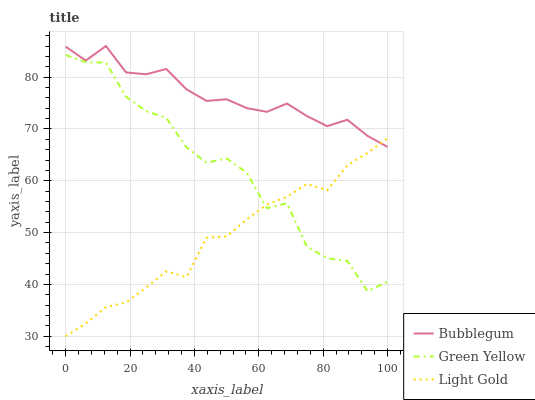Does Light Gold have the minimum area under the curve?
Answer yes or no. Yes. Does Bubblegum have the maximum area under the curve?
Answer yes or no. Yes. Does Bubblegum have the minimum area under the curve?
Answer yes or no. No. Does Light Gold have the maximum area under the curve?
Answer yes or no. No. Is Light Gold the smoothest?
Answer yes or no. Yes. Is Green Yellow the roughest?
Answer yes or no. Yes. Is Bubblegum the smoothest?
Answer yes or no. No. Is Bubblegum the roughest?
Answer yes or no. No. Does Light Gold have the lowest value?
Answer yes or no. Yes. Does Bubblegum have the lowest value?
Answer yes or no. No. Does Bubblegum have the highest value?
Answer yes or no. Yes. Does Light Gold have the highest value?
Answer yes or no. No. Is Green Yellow less than Bubblegum?
Answer yes or no. Yes. Is Bubblegum greater than Green Yellow?
Answer yes or no. Yes. Does Light Gold intersect Bubblegum?
Answer yes or no. Yes. Is Light Gold less than Bubblegum?
Answer yes or no. No. Is Light Gold greater than Bubblegum?
Answer yes or no. No. Does Green Yellow intersect Bubblegum?
Answer yes or no. No. 